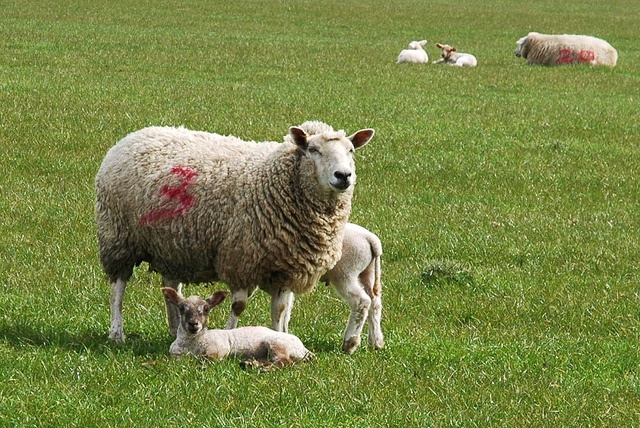Describe the objects in this image and their specific colors. I can see sheep in olive, black, gray, darkgreen, and lightgray tones, sheep in olive, lightgray, gray, darkgreen, and black tones, sheep in olive, ivory, darkgreen, and darkgray tones, sheep in olive, lightgray, gray, and tan tones, and sheep in olive, white, and darkgray tones in this image. 